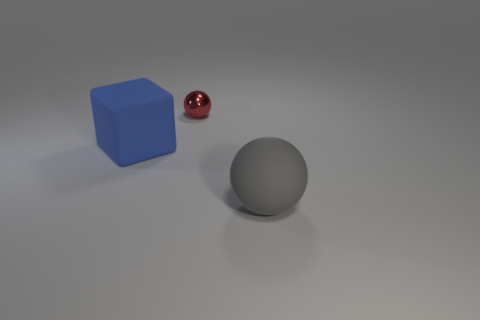Add 1 cyan rubber balls. How many objects exist? 4 Subtract all blocks. How many objects are left? 2 Subtract all shiny blocks. Subtract all tiny red things. How many objects are left? 2 Add 3 spheres. How many spheres are left? 5 Add 3 gray things. How many gray things exist? 4 Subtract 0 cyan balls. How many objects are left? 3 